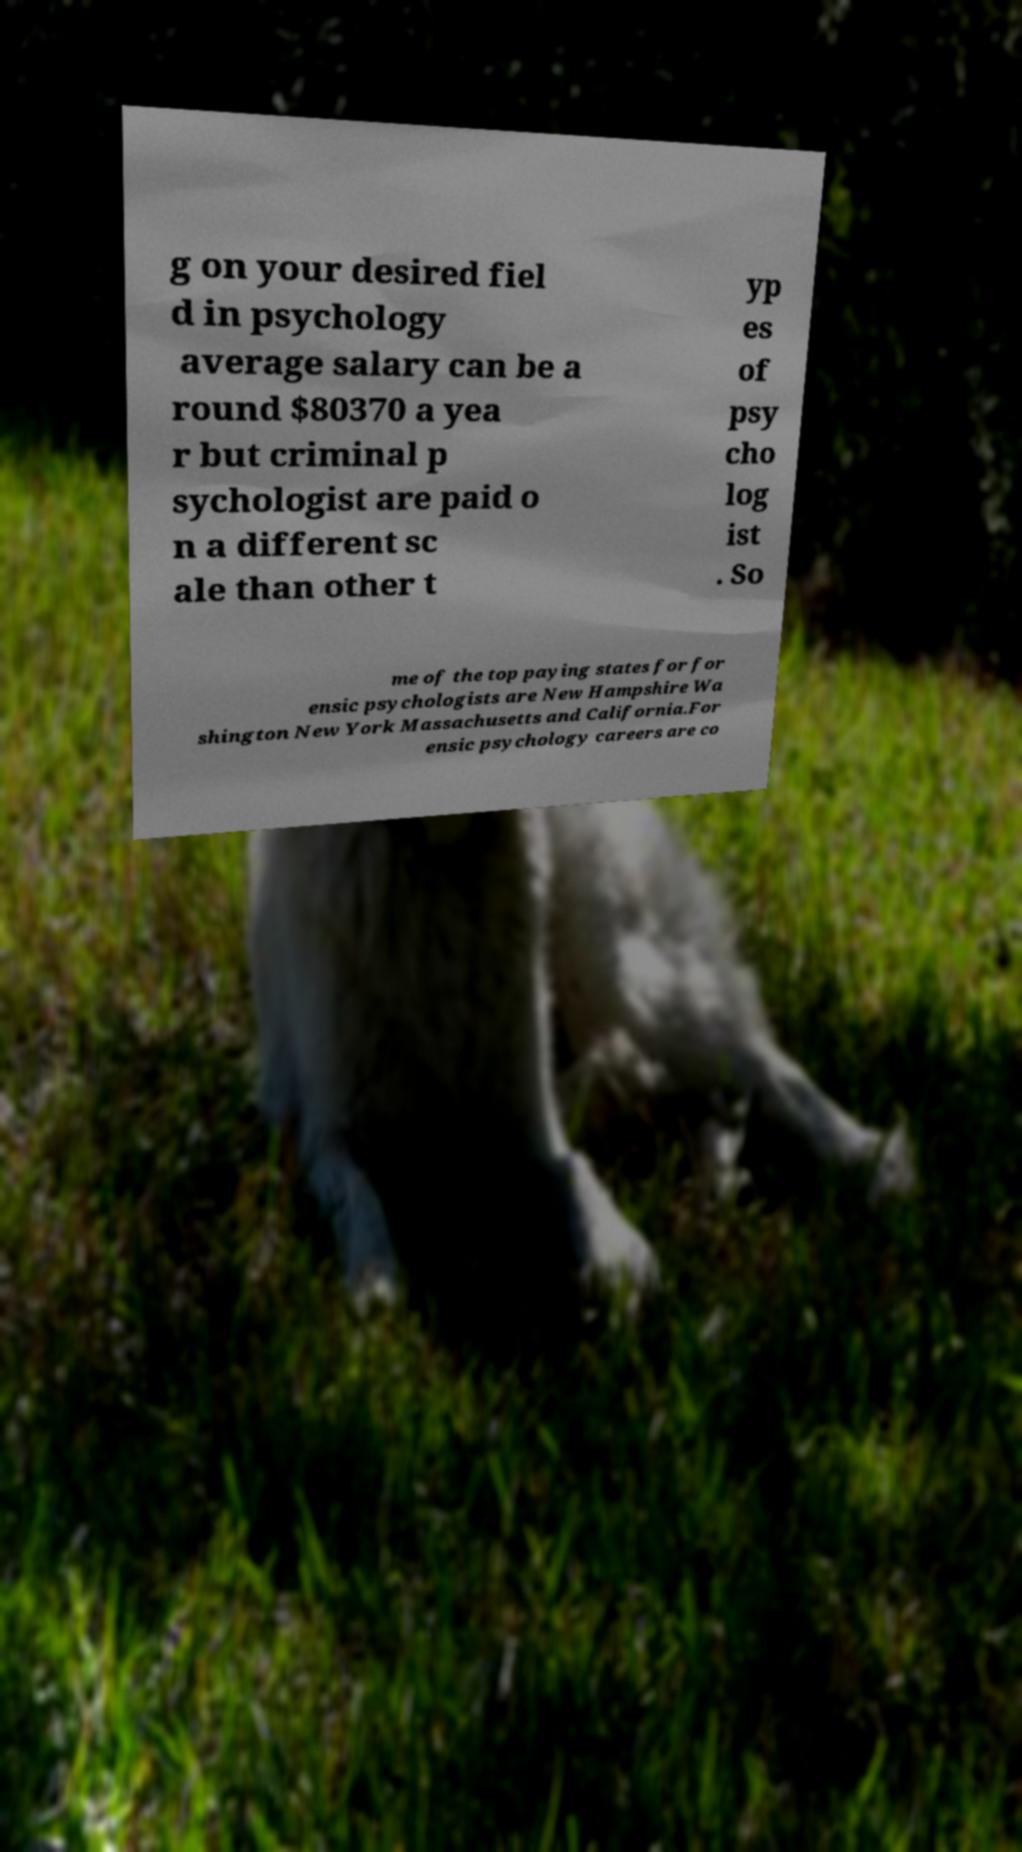Could you assist in decoding the text presented in this image and type it out clearly? g on your desired fiel d in psychology average salary can be a round $80370 a yea r but criminal p sychologist are paid o n a different sc ale than other t yp es of psy cho log ist . So me of the top paying states for for ensic psychologists are New Hampshire Wa shington New York Massachusetts and California.For ensic psychology careers are co 